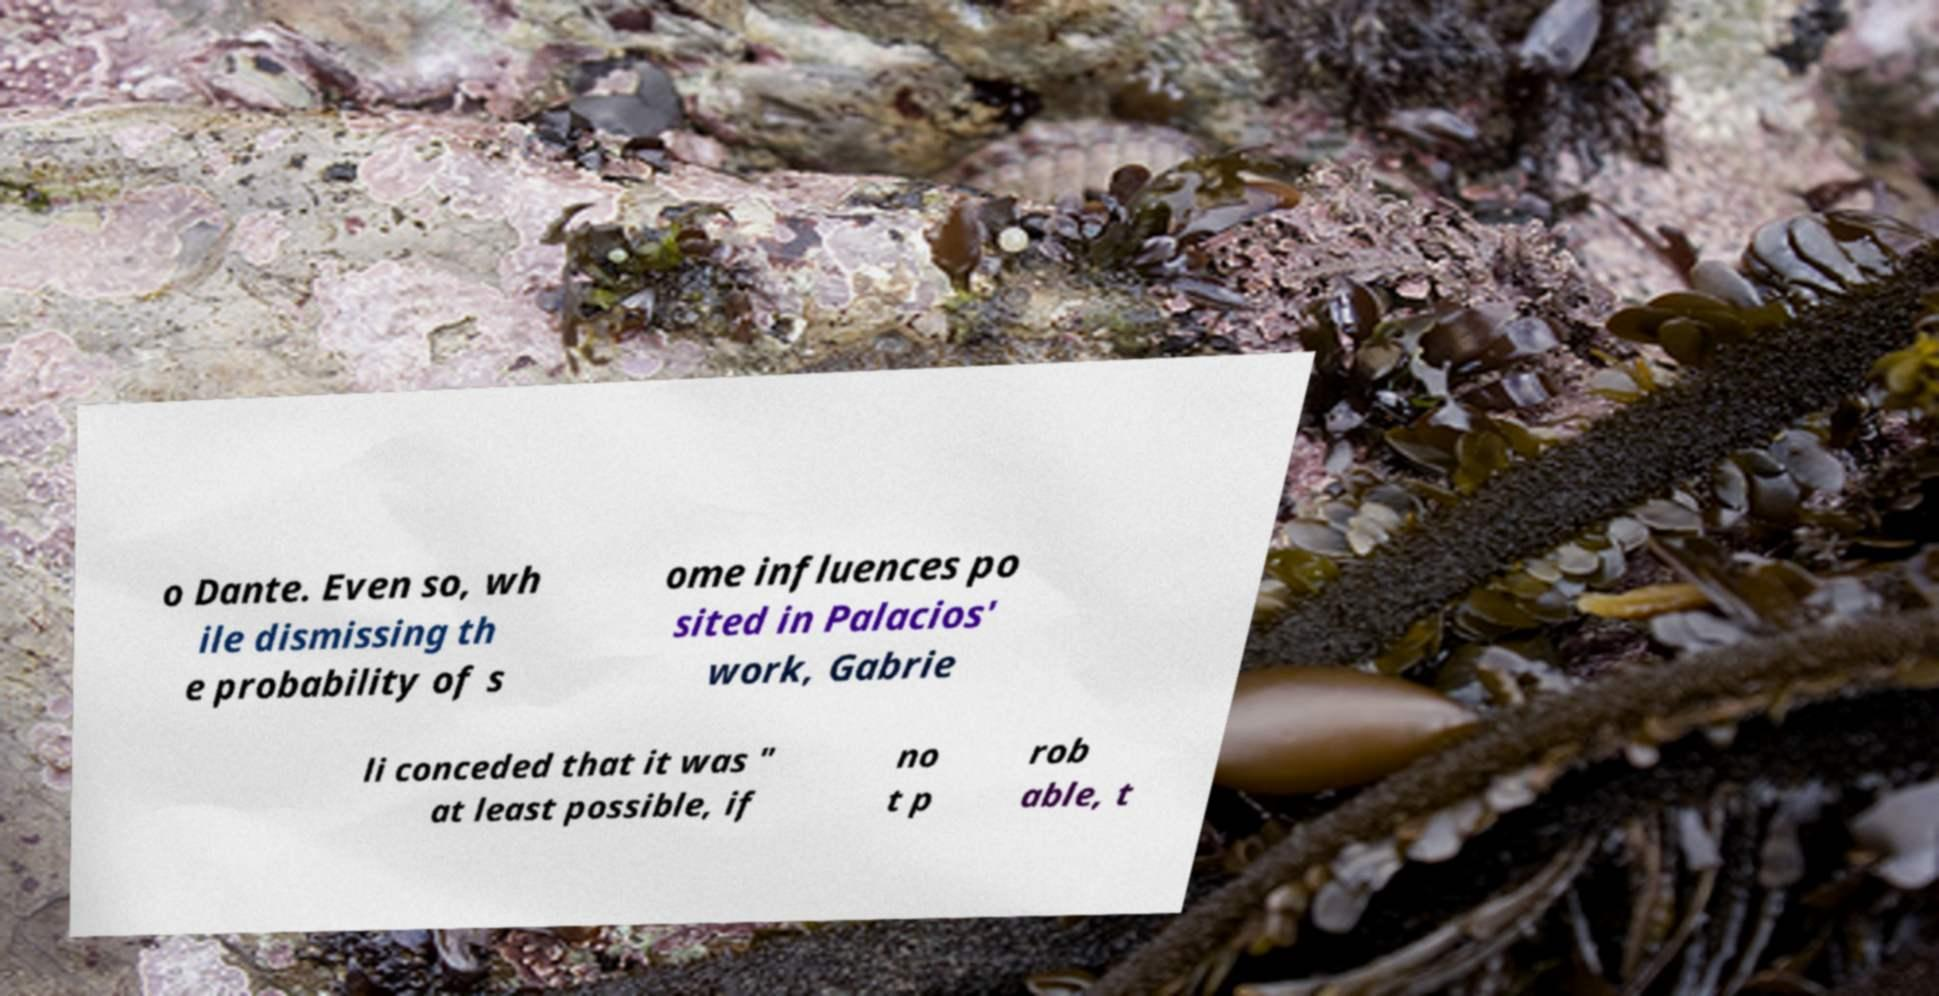There's text embedded in this image that I need extracted. Can you transcribe it verbatim? o Dante. Even so, wh ile dismissing th e probability of s ome influences po sited in Palacios' work, Gabrie li conceded that it was " at least possible, if no t p rob able, t 